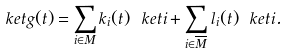<formula> <loc_0><loc_0><loc_500><loc_500>\ k e t { g ( t ) } = \sum _ { i \in M } k _ { i } ( t ) \ k e t { i } + \sum _ { i \in \overline { M } } l _ { i } ( t ) \ k e t { i } .</formula> 